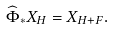Convert formula to latex. <formula><loc_0><loc_0><loc_500><loc_500>\widehat { \Phi } _ { \ast } X _ { H } = X _ { H + F } .</formula> 